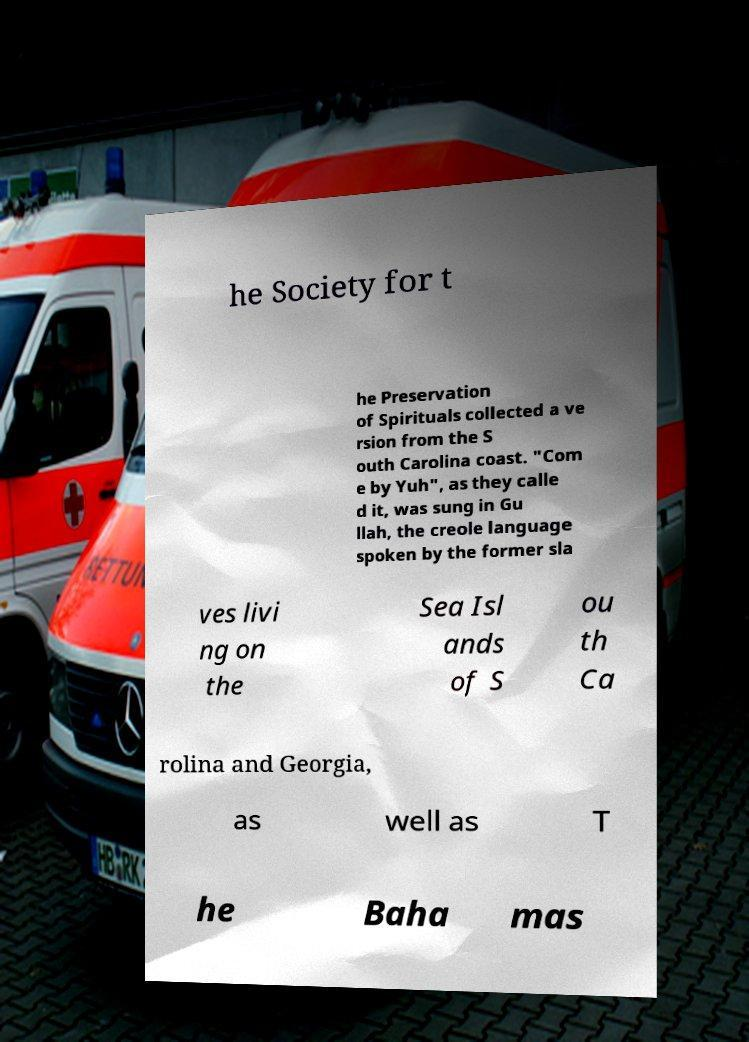Please read and relay the text visible in this image. What does it say? he Society for t he Preservation of Spirituals collected a ve rsion from the S outh Carolina coast. "Com e by Yuh", as they calle d it, was sung in Gu llah, the creole language spoken by the former sla ves livi ng on the Sea Isl ands of S ou th Ca rolina and Georgia, as well as T he Baha mas 